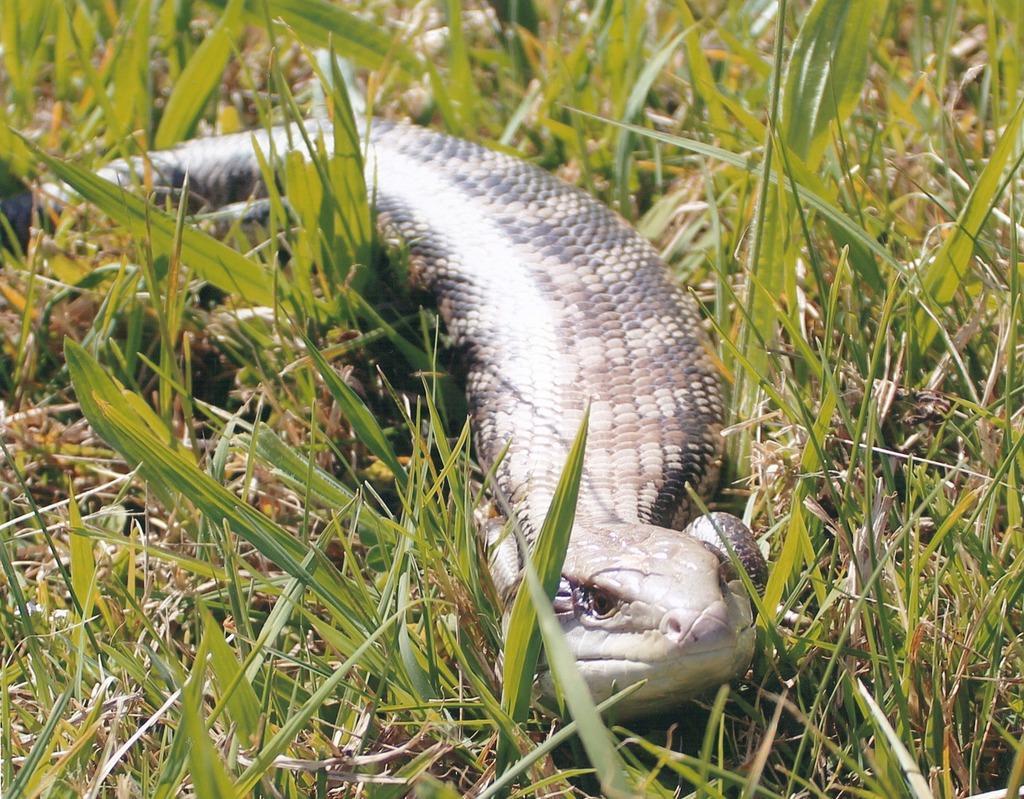Describe this image in one or two sentences. In this image I can see a snake on grass. 